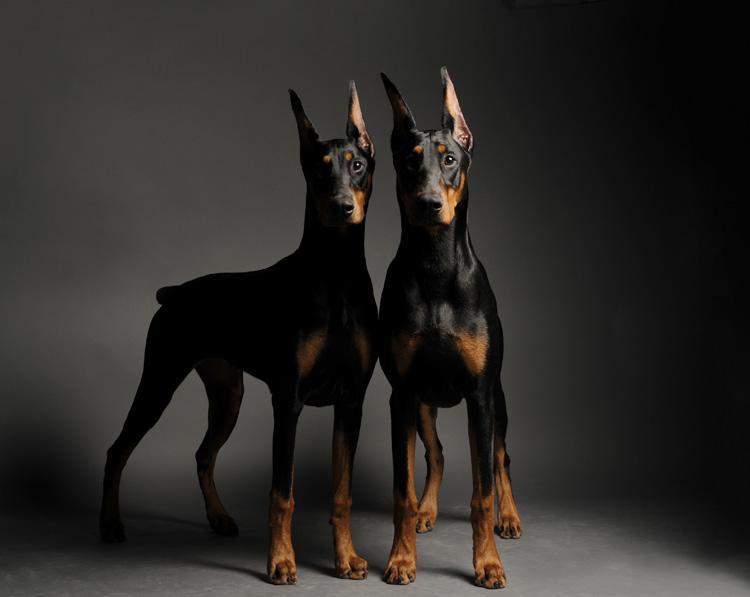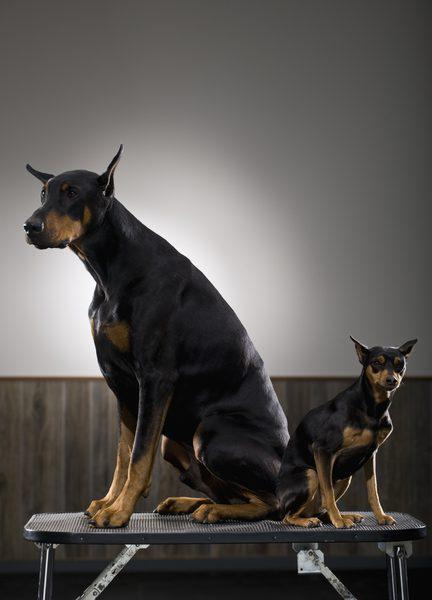The first image is the image on the left, the second image is the image on the right. Considering the images on both sides, is "The combined images include at least four dogs, with at least two dogs in sitting poses and two dogs facing directly forward." valid? Answer yes or no. Yes. The first image is the image on the left, the second image is the image on the right. Examine the images to the left and right. Is the description "There are dobermans standing." accurate? Answer yes or no. Yes. 